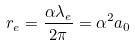Convert formula to latex. <formula><loc_0><loc_0><loc_500><loc_500>r _ { e } = \frac { \alpha \lambda _ { e } } { 2 \pi } = \alpha ^ { 2 } a _ { 0 }</formula> 